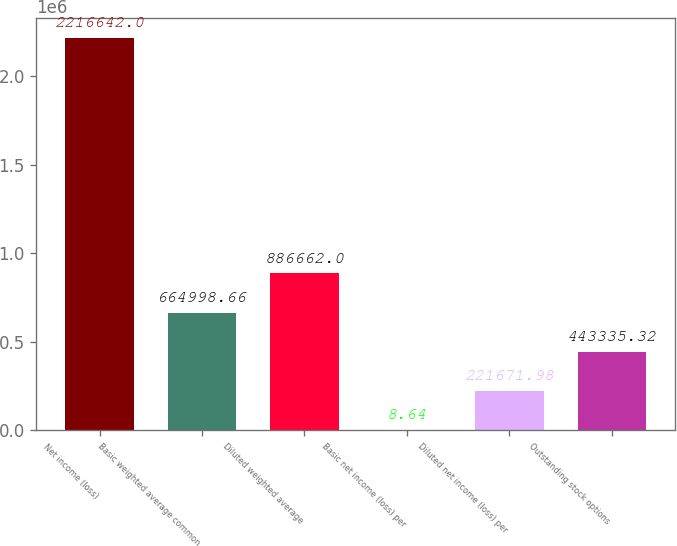<chart> <loc_0><loc_0><loc_500><loc_500><bar_chart><fcel>Net income (loss)<fcel>Basic weighted average common<fcel>Diluted weighted average<fcel>Basic net income (loss) per<fcel>Diluted net income (loss) per<fcel>Outstanding stock options<nl><fcel>2.21664e+06<fcel>664999<fcel>886662<fcel>8.64<fcel>221672<fcel>443335<nl></chart> 